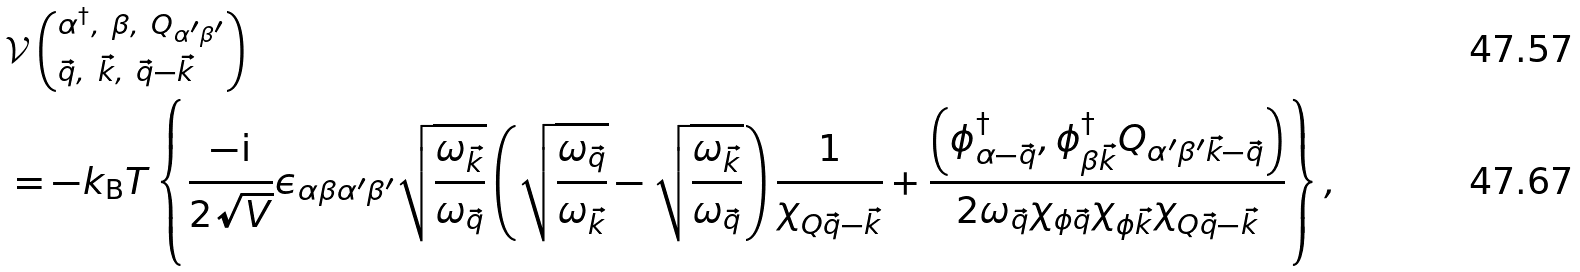Convert formula to latex. <formula><loc_0><loc_0><loc_500><loc_500>& \mathcal { V } \left ( _ { \vec { q } , \ \vec { k } , \ \vec { q } - \vec { k } } ^ { \alpha ^ { \dagger } , \ \beta , \ Q _ { \alpha ^ { \prime } \beta ^ { \prime } } } \right ) \\ & = - k _ { \text  B}T \left\{ \frac{-\text  i}{2\sqrt{V} } \epsilon _ { \alpha \beta \alpha ^ { \prime } \beta ^ { \prime } } \sqrt { \frac { \omega _ { \vec { k } } } { \omega _ { \vec { q } } } } \left ( \sqrt { \frac { \omega _ { \vec { q } } } { \omega _ { \vec { k } } } } - \sqrt { \frac { \omega _ { \vec { k } } } { \omega _ { \vec { q } } } } \right ) \frac { 1 } { \chi _ { Q \vec { q } - \vec { k } } } + \frac { \left ( \phi _ { \alpha - \vec { q } } ^ { \dagger } , \phi _ { \beta \vec { k } } ^ { \dagger } Q _ { \alpha ^ { \prime } \beta ^ { \prime } \vec { k } - \vec { q } } \right ) } { 2 \omega _ { \vec { q } } \chi _ { \phi \vec { q } } \chi _ { \phi \vec { k } } \chi _ { Q \vec { q } - \vec { k } } } \right \} ,</formula> 